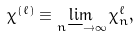Convert formula to latex. <formula><loc_0><loc_0><loc_500><loc_500>\chi ^ { ( \ell ) } \equiv \lim _ { n \longrightarrow \infty } \chi _ { n } ^ { \ell } ,</formula> 